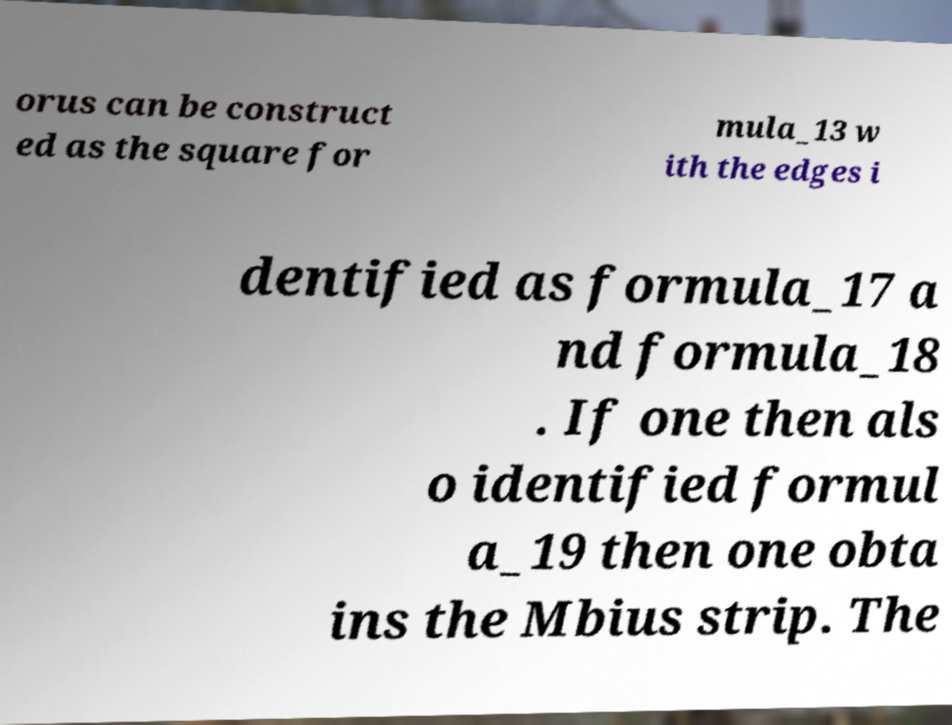Can you accurately transcribe the text from the provided image for me? orus can be construct ed as the square for mula_13 w ith the edges i dentified as formula_17 a nd formula_18 . If one then als o identified formul a_19 then one obta ins the Mbius strip. The 